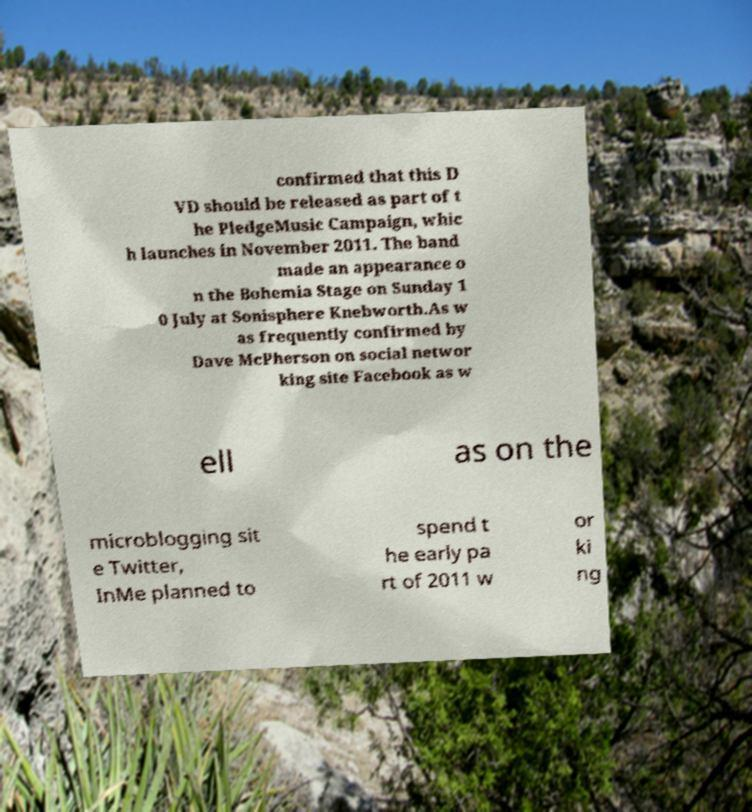Please read and relay the text visible in this image. What does it say? confirmed that this D VD should be released as part of t he PledgeMusic Campaign, whic h launches in November 2011. The band made an appearance o n the Bohemia Stage on Sunday 1 0 July at Sonisphere Knebworth.As w as frequently confirmed by Dave McPherson on social networ king site Facebook as w ell as on the microblogging sit e Twitter, InMe planned to spend t he early pa rt of 2011 w or ki ng 